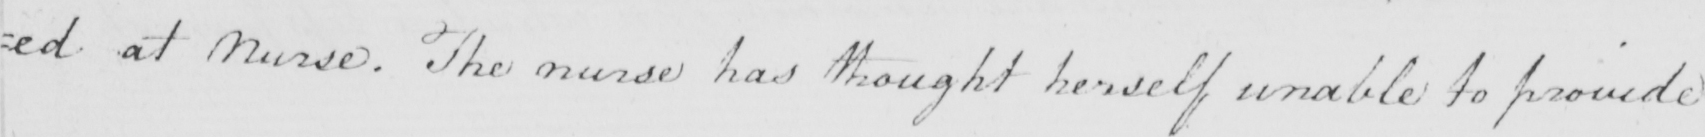Please provide the text content of this handwritten line. =ed at Nurse . The Nurse has thought herself unable to provide 